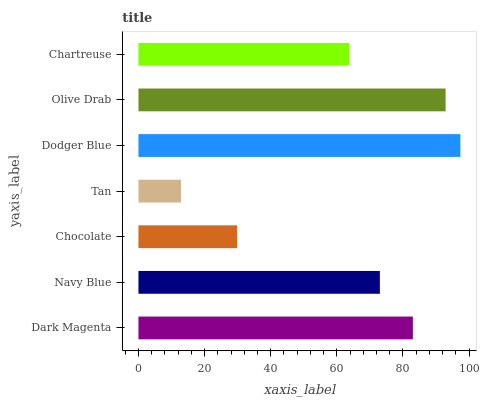Is Tan the minimum?
Answer yes or no. Yes. Is Dodger Blue the maximum?
Answer yes or no. Yes. Is Navy Blue the minimum?
Answer yes or no. No. Is Navy Blue the maximum?
Answer yes or no. No. Is Dark Magenta greater than Navy Blue?
Answer yes or no. Yes. Is Navy Blue less than Dark Magenta?
Answer yes or no. Yes. Is Navy Blue greater than Dark Magenta?
Answer yes or no. No. Is Dark Magenta less than Navy Blue?
Answer yes or no. No. Is Navy Blue the high median?
Answer yes or no. Yes. Is Navy Blue the low median?
Answer yes or no. Yes. Is Chocolate the high median?
Answer yes or no. No. Is Dark Magenta the low median?
Answer yes or no. No. 